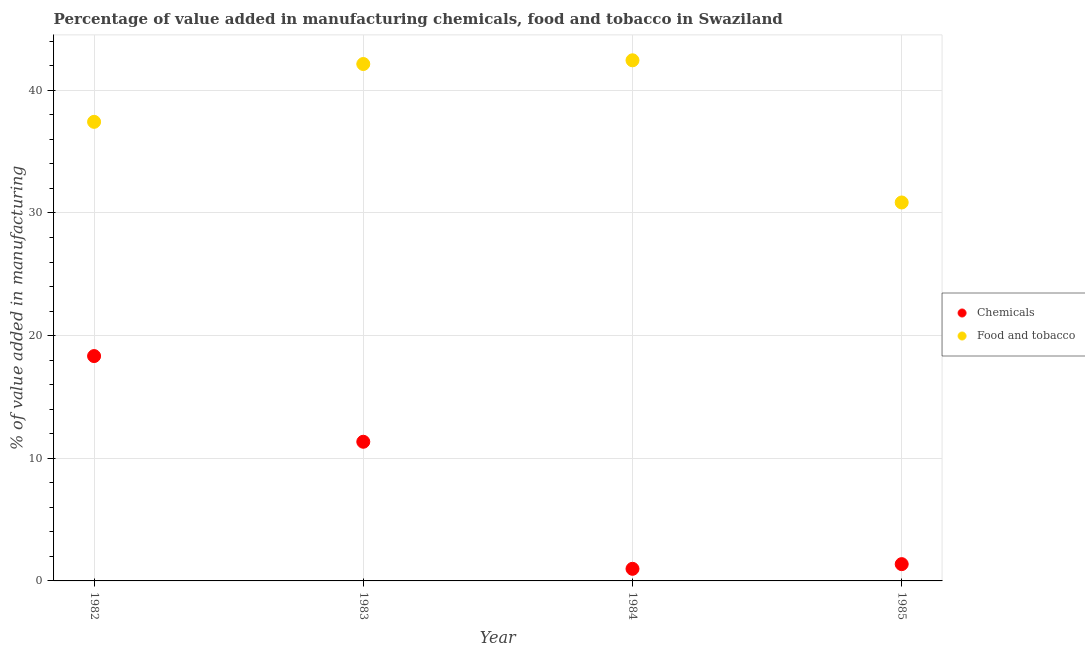Is the number of dotlines equal to the number of legend labels?
Make the answer very short. Yes. What is the value added by manufacturing food and tobacco in 1983?
Your answer should be compact. 42.15. Across all years, what is the maximum value added by  manufacturing chemicals?
Provide a succinct answer. 18.33. Across all years, what is the minimum value added by  manufacturing chemicals?
Provide a succinct answer. 0.99. In which year was the value added by manufacturing food and tobacco maximum?
Ensure brevity in your answer.  1984. In which year was the value added by  manufacturing chemicals minimum?
Provide a succinct answer. 1984. What is the total value added by manufacturing food and tobacco in the graph?
Give a very brief answer. 152.89. What is the difference between the value added by  manufacturing chemicals in 1982 and that in 1983?
Keep it short and to the point. 6.99. What is the difference between the value added by  manufacturing chemicals in 1982 and the value added by manufacturing food and tobacco in 1984?
Your response must be concise. -24.12. What is the average value added by  manufacturing chemicals per year?
Make the answer very short. 8.01. In the year 1982, what is the difference between the value added by  manufacturing chemicals and value added by manufacturing food and tobacco?
Your answer should be compact. -19.1. What is the ratio of the value added by  manufacturing chemicals in 1982 to that in 1985?
Keep it short and to the point. 13.39. Is the difference between the value added by manufacturing food and tobacco in 1984 and 1985 greater than the difference between the value added by  manufacturing chemicals in 1984 and 1985?
Ensure brevity in your answer.  Yes. What is the difference between the highest and the second highest value added by manufacturing food and tobacco?
Offer a terse response. 0.3. What is the difference between the highest and the lowest value added by manufacturing food and tobacco?
Your answer should be compact. 11.59. In how many years, is the value added by manufacturing food and tobacco greater than the average value added by manufacturing food and tobacco taken over all years?
Ensure brevity in your answer.  2. Are the values on the major ticks of Y-axis written in scientific E-notation?
Keep it short and to the point. No. Does the graph contain any zero values?
Your response must be concise. No. Where does the legend appear in the graph?
Make the answer very short. Center right. How many legend labels are there?
Provide a succinct answer. 2. How are the legend labels stacked?
Provide a short and direct response. Vertical. What is the title of the graph?
Ensure brevity in your answer.  Percentage of value added in manufacturing chemicals, food and tobacco in Swaziland. What is the label or title of the X-axis?
Ensure brevity in your answer.  Year. What is the label or title of the Y-axis?
Ensure brevity in your answer.  % of value added in manufacturing. What is the % of value added in manufacturing in Chemicals in 1982?
Your response must be concise. 18.33. What is the % of value added in manufacturing in Food and tobacco in 1982?
Give a very brief answer. 37.43. What is the % of value added in manufacturing in Chemicals in 1983?
Your answer should be compact. 11.35. What is the % of value added in manufacturing of Food and tobacco in 1983?
Your response must be concise. 42.15. What is the % of value added in manufacturing in Chemicals in 1984?
Provide a short and direct response. 0.99. What is the % of value added in manufacturing in Food and tobacco in 1984?
Provide a short and direct response. 42.45. What is the % of value added in manufacturing of Chemicals in 1985?
Your answer should be compact. 1.37. What is the % of value added in manufacturing in Food and tobacco in 1985?
Make the answer very short. 30.86. Across all years, what is the maximum % of value added in manufacturing in Chemicals?
Give a very brief answer. 18.33. Across all years, what is the maximum % of value added in manufacturing of Food and tobacco?
Provide a succinct answer. 42.45. Across all years, what is the minimum % of value added in manufacturing of Chemicals?
Provide a succinct answer. 0.99. Across all years, what is the minimum % of value added in manufacturing of Food and tobacco?
Offer a terse response. 30.86. What is the total % of value added in manufacturing of Chemicals in the graph?
Give a very brief answer. 32.04. What is the total % of value added in manufacturing in Food and tobacco in the graph?
Ensure brevity in your answer.  152.89. What is the difference between the % of value added in manufacturing in Chemicals in 1982 and that in 1983?
Keep it short and to the point. 6.99. What is the difference between the % of value added in manufacturing of Food and tobacco in 1982 and that in 1983?
Keep it short and to the point. -4.72. What is the difference between the % of value added in manufacturing of Chemicals in 1982 and that in 1984?
Your answer should be compact. 17.35. What is the difference between the % of value added in manufacturing of Food and tobacco in 1982 and that in 1984?
Ensure brevity in your answer.  -5.02. What is the difference between the % of value added in manufacturing in Chemicals in 1982 and that in 1985?
Provide a succinct answer. 16.96. What is the difference between the % of value added in manufacturing in Food and tobacco in 1982 and that in 1985?
Offer a terse response. 6.57. What is the difference between the % of value added in manufacturing in Chemicals in 1983 and that in 1984?
Give a very brief answer. 10.36. What is the difference between the % of value added in manufacturing in Food and tobacco in 1983 and that in 1984?
Your answer should be very brief. -0.3. What is the difference between the % of value added in manufacturing of Chemicals in 1983 and that in 1985?
Offer a terse response. 9.98. What is the difference between the % of value added in manufacturing of Food and tobacco in 1983 and that in 1985?
Keep it short and to the point. 11.29. What is the difference between the % of value added in manufacturing in Chemicals in 1984 and that in 1985?
Offer a terse response. -0.38. What is the difference between the % of value added in manufacturing of Food and tobacco in 1984 and that in 1985?
Provide a short and direct response. 11.59. What is the difference between the % of value added in manufacturing of Chemicals in 1982 and the % of value added in manufacturing of Food and tobacco in 1983?
Ensure brevity in your answer.  -23.81. What is the difference between the % of value added in manufacturing in Chemicals in 1982 and the % of value added in manufacturing in Food and tobacco in 1984?
Ensure brevity in your answer.  -24.12. What is the difference between the % of value added in manufacturing of Chemicals in 1982 and the % of value added in manufacturing of Food and tobacco in 1985?
Your response must be concise. -12.52. What is the difference between the % of value added in manufacturing of Chemicals in 1983 and the % of value added in manufacturing of Food and tobacco in 1984?
Provide a short and direct response. -31.1. What is the difference between the % of value added in manufacturing of Chemicals in 1983 and the % of value added in manufacturing of Food and tobacco in 1985?
Make the answer very short. -19.51. What is the difference between the % of value added in manufacturing in Chemicals in 1984 and the % of value added in manufacturing in Food and tobacco in 1985?
Make the answer very short. -29.87. What is the average % of value added in manufacturing in Chemicals per year?
Keep it short and to the point. 8.01. What is the average % of value added in manufacturing of Food and tobacco per year?
Your answer should be very brief. 38.22. In the year 1982, what is the difference between the % of value added in manufacturing of Chemicals and % of value added in manufacturing of Food and tobacco?
Your response must be concise. -19.1. In the year 1983, what is the difference between the % of value added in manufacturing of Chemicals and % of value added in manufacturing of Food and tobacco?
Ensure brevity in your answer.  -30.8. In the year 1984, what is the difference between the % of value added in manufacturing of Chemicals and % of value added in manufacturing of Food and tobacco?
Your answer should be very brief. -41.46. In the year 1985, what is the difference between the % of value added in manufacturing of Chemicals and % of value added in manufacturing of Food and tobacco?
Your answer should be compact. -29.49. What is the ratio of the % of value added in manufacturing in Chemicals in 1982 to that in 1983?
Your answer should be compact. 1.62. What is the ratio of the % of value added in manufacturing of Food and tobacco in 1982 to that in 1983?
Provide a succinct answer. 0.89. What is the ratio of the % of value added in manufacturing in Chemicals in 1982 to that in 1984?
Give a very brief answer. 18.58. What is the ratio of the % of value added in manufacturing of Food and tobacco in 1982 to that in 1984?
Provide a short and direct response. 0.88. What is the ratio of the % of value added in manufacturing of Chemicals in 1982 to that in 1985?
Make the answer very short. 13.39. What is the ratio of the % of value added in manufacturing in Food and tobacco in 1982 to that in 1985?
Make the answer very short. 1.21. What is the ratio of the % of value added in manufacturing of Chemicals in 1983 to that in 1984?
Your answer should be compact. 11.5. What is the ratio of the % of value added in manufacturing in Food and tobacco in 1983 to that in 1984?
Your answer should be very brief. 0.99. What is the ratio of the % of value added in manufacturing of Chemicals in 1983 to that in 1985?
Offer a terse response. 8.29. What is the ratio of the % of value added in manufacturing of Food and tobacco in 1983 to that in 1985?
Your answer should be compact. 1.37. What is the ratio of the % of value added in manufacturing of Chemicals in 1984 to that in 1985?
Provide a short and direct response. 0.72. What is the ratio of the % of value added in manufacturing of Food and tobacco in 1984 to that in 1985?
Ensure brevity in your answer.  1.38. What is the difference between the highest and the second highest % of value added in manufacturing in Chemicals?
Keep it short and to the point. 6.99. What is the difference between the highest and the second highest % of value added in manufacturing in Food and tobacco?
Give a very brief answer. 0.3. What is the difference between the highest and the lowest % of value added in manufacturing in Chemicals?
Offer a terse response. 17.35. What is the difference between the highest and the lowest % of value added in manufacturing of Food and tobacco?
Your response must be concise. 11.59. 